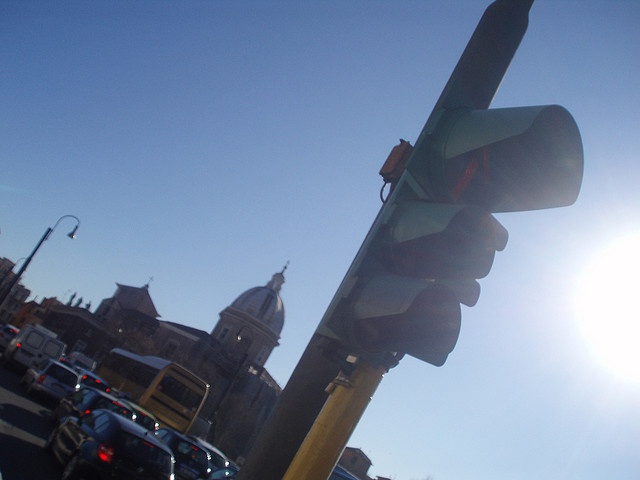Describe the objects in this image and their specific colors. I can see traffic light in blue, gray, darkblue, and black tones, bus in blue, black, gray, and darkblue tones, car in blue, black, navy, darkblue, and maroon tones, car in blue, black, gray, and darkblue tones, and car in blue, black, darkblue, and gray tones in this image. 